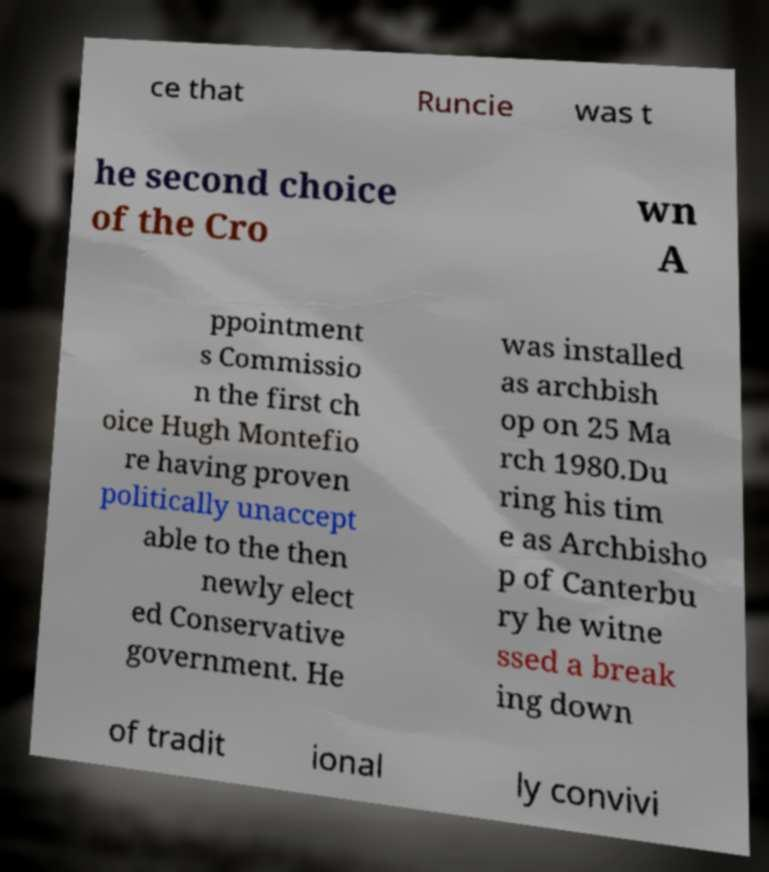There's text embedded in this image that I need extracted. Can you transcribe it verbatim? ce that Runcie was t he second choice of the Cro wn A ppointment s Commissio n the first ch oice Hugh Montefio re having proven politically unaccept able to the then newly elect ed Conservative government. He was installed as archbish op on 25 Ma rch 1980.Du ring his tim e as Archbisho p of Canterbu ry he witne ssed a break ing down of tradit ional ly convivi 